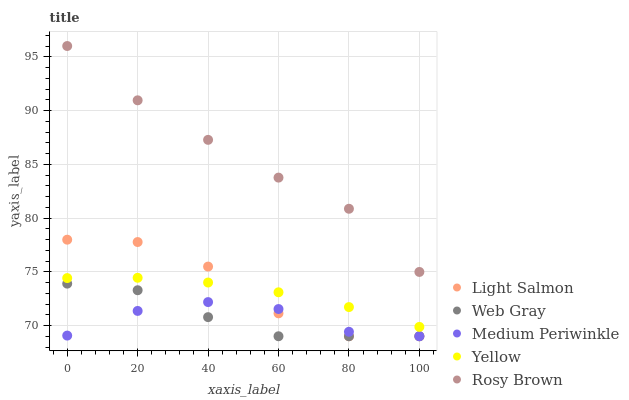Does Web Gray have the minimum area under the curve?
Answer yes or no. Yes. Does Rosy Brown have the maximum area under the curve?
Answer yes or no. Yes. Does Medium Periwinkle have the minimum area under the curve?
Answer yes or no. No. Does Medium Periwinkle have the maximum area under the curve?
Answer yes or no. No. Is Yellow the smoothest?
Answer yes or no. Yes. Is Light Salmon the roughest?
Answer yes or no. Yes. Is Web Gray the smoothest?
Answer yes or no. No. Is Web Gray the roughest?
Answer yes or no. No. Does Light Salmon have the lowest value?
Answer yes or no. Yes. Does Rosy Brown have the lowest value?
Answer yes or no. No. Does Rosy Brown have the highest value?
Answer yes or no. Yes. Does Web Gray have the highest value?
Answer yes or no. No. Is Yellow less than Rosy Brown?
Answer yes or no. Yes. Is Rosy Brown greater than Medium Periwinkle?
Answer yes or no. Yes. Does Light Salmon intersect Web Gray?
Answer yes or no. Yes. Is Light Salmon less than Web Gray?
Answer yes or no. No. Is Light Salmon greater than Web Gray?
Answer yes or no. No. Does Yellow intersect Rosy Brown?
Answer yes or no. No. 